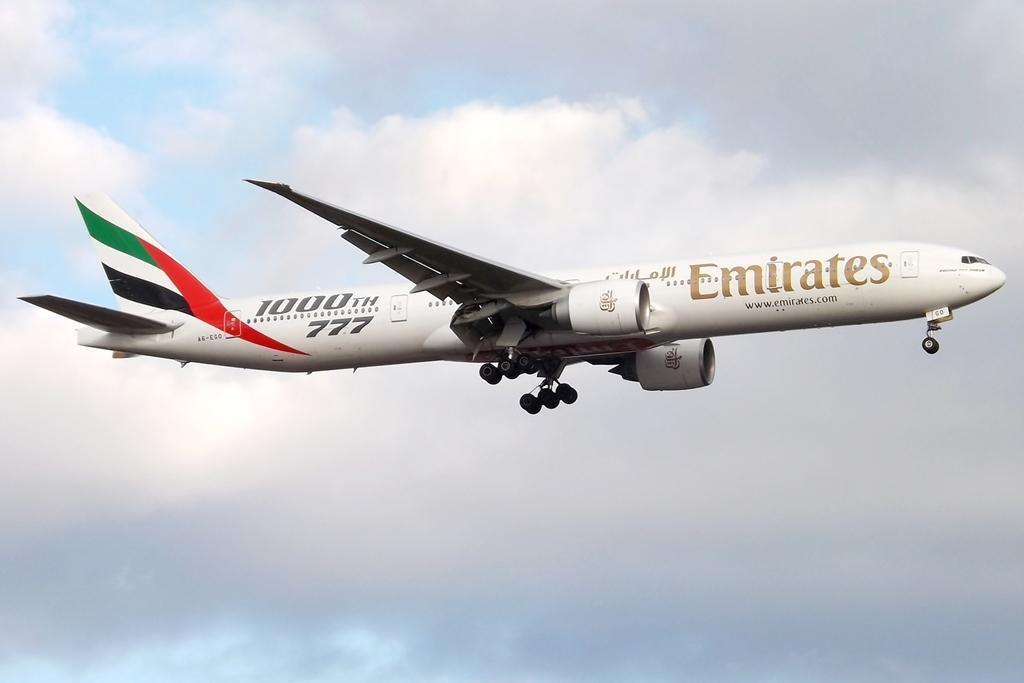What type of airplane is in the image? There is an Emirates airplane in the image. What is the airplane doing in the image? The airplane is flying in the sky. What can be seen in the background of the image? The sky is visible in the image. What is the condition of the sky in the image? Clouds are present in the sky. What color is the eye of the person sitting in the airplane in the image? There is no person or eye visible in the image; it only shows an Emirates airplane flying in the sky. 